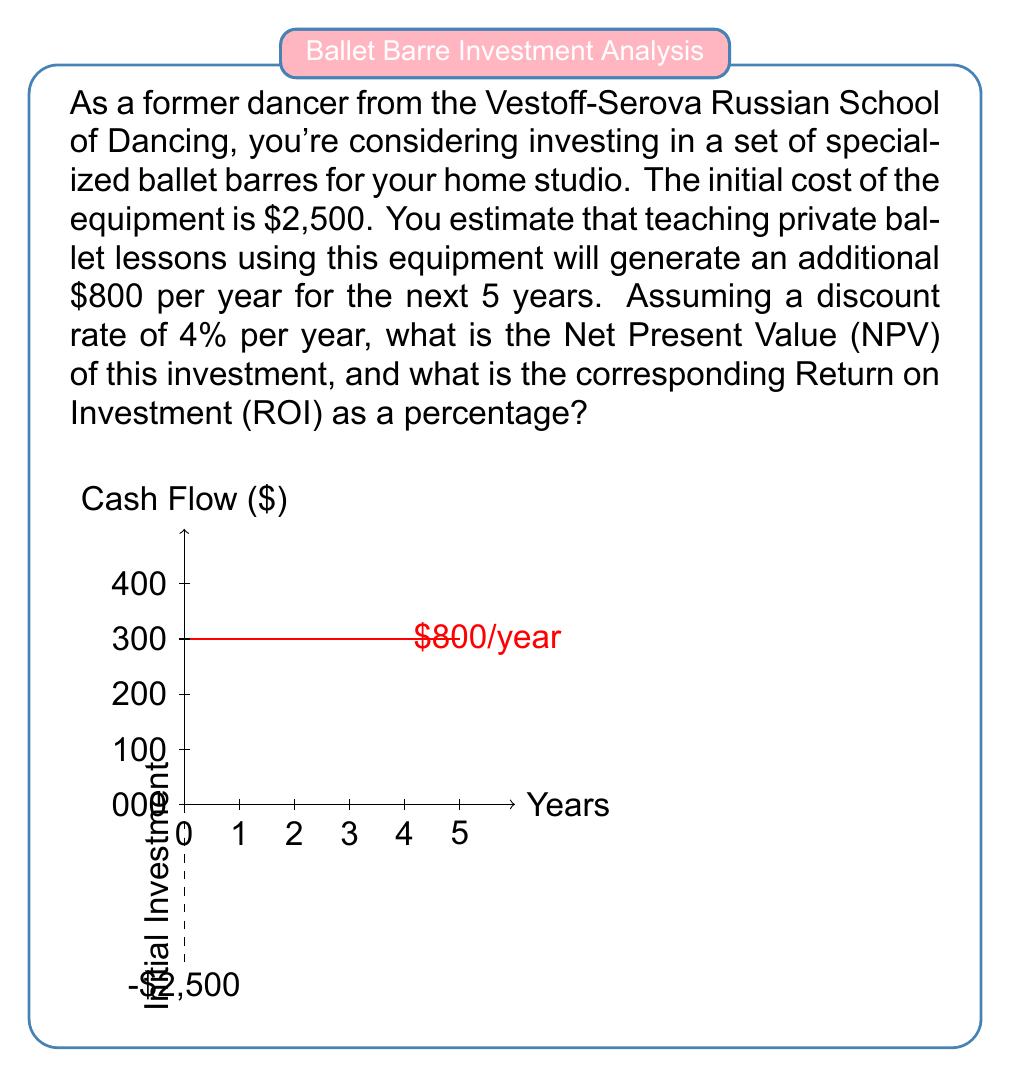Provide a solution to this math problem. Let's approach this problem step-by-step:

1) First, we need to calculate the Present Value (PV) of the future cash flows. The formula for PV is:

   $PV = \frac{CF_t}{(1+r)^t}$

   where $CF_t$ is the cash flow at time t, r is the discount rate, and t is the time period.

2) We have a cash flow of $800 per year for 5 years. Let's calculate the PV for each year:

   Year 1: $PV_1 = \frac{800}{(1+0.04)^1} = 769.23$
   Year 2: $PV_2 = \frac{800}{(1+0.04)^2} = 739.64$
   Year 3: $PV_3 = \frac{800}{(1+0.04)^3} = 711.19$
   Year 4: $PV_4 = \frac{800}{(1+0.04)^4} = 683.84$
   Year 5: $PV_5 = \frac{800}{(1+0.04)^5} = 657.54$

3) The total Present Value is the sum of these:

   $PV_{total} = 769.23 + 739.64 + 711.19 + 683.84 + 657.54 = 3,561.44$

4) The Net Present Value (NPV) is the difference between the total PV and the initial investment:

   $NPV = PV_{total} - Initial Investment = 3,561.44 - 2,500 = 1,061.44$

5) To calculate the Return on Investment (ROI), we use the formula:

   $ROI = \frac{Gain from Investment - Cost of Investment}{Cost of Investment} \times 100\%$

   $ROI = \frac{1,061.44}{2,500} \times 100\% = 42.46\%$

Therefore, the NPV of the investment is $1,061.44, and the ROI is 42.46%.
Answer: NPV = $1,061.44, ROI = 42.46% 